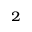Convert formula to latex. <formula><loc_0><loc_0><loc_500><loc_500>^ { 2 }</formula> 